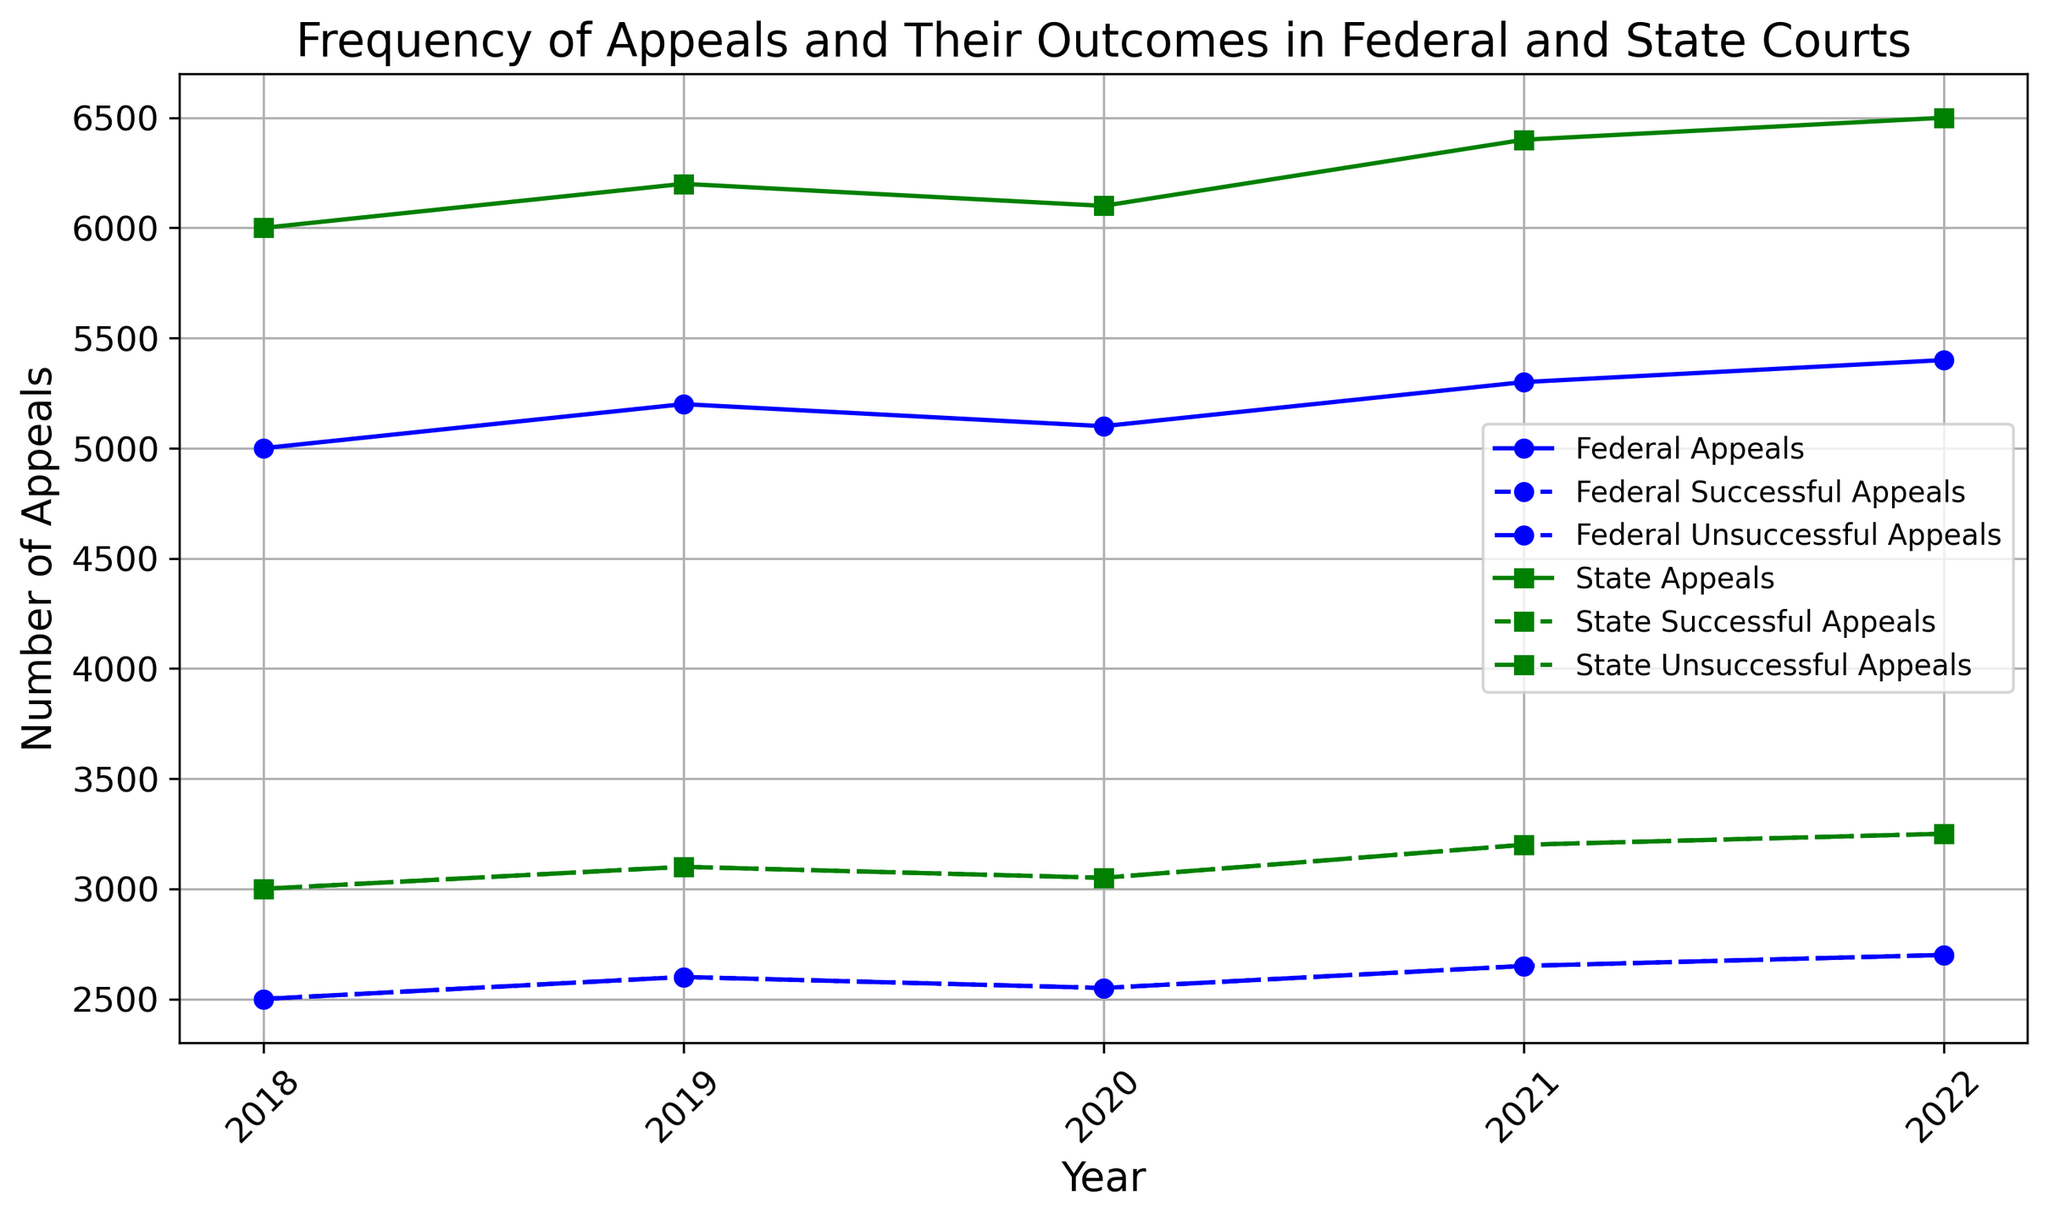what is the total number of appeals in 2020 for both federal and state courts? To find the total number of appeals in 2020 for both courts, sum the number of appeals for federal and state courts in 2020. Federal: 5100, State: 6100. Total = 5100 + 6100 = 11200
Answer: 11200 Which type of court had more unsuccessful appeals in 2021? Compare the number of unsuccessful appeals for federal and state courts in 2021. Federal: 2650, State: 3200. State courts had more unsuccessful appeals.
Answer: State In which year did federal courts have the highest number of successful appeals? Look at the number of successful appeals for federal courts across different years. The highest number is in 2022, with 2700 successful appeals.
Answer: 2022 How does the trend in the number of appeals compare between federal and state courts from 2018 to 2022? Examine the number of appeals over the years for both federal and state courts. Both show increasing trends, with state courts consistently having more appeals each year.
Answer: Increasing trend for both What is the difference in the number of successful appeals between federal and state courts in 2022? Subtract the number of successful appeals in federal courts from the number in state courts for 2022. State: 3250, Federal: 2700. Difference = 3250 - 2700 = 550
Answer: 550 How consistent was the number of unsuccessful appeals in federal courts from 2018 to 2022? The number of unsuccessful appeals in federal courts remained constant at 2500 in 2018 and 2019, then increased to 2550 in 2020, 2650 in 2021, and finally 2700 in 2022.
Answer: Generally consistent with slight increases Is there a year in which state courts had an equal number of successful and unsuccessful appeals? From the data, check if there are equal values for successful and unsuccessful appeals in any year for state courts. In all years (2018-2022), state courts had an equal number of successful and unsuccessful appeals.
Answer: All years (2018-2022) What are the colors used to represent federal and state courts in the plot? Federal courts are represented in blue, and state courts are represented in green.
Answer: Blue for federal, green for state 